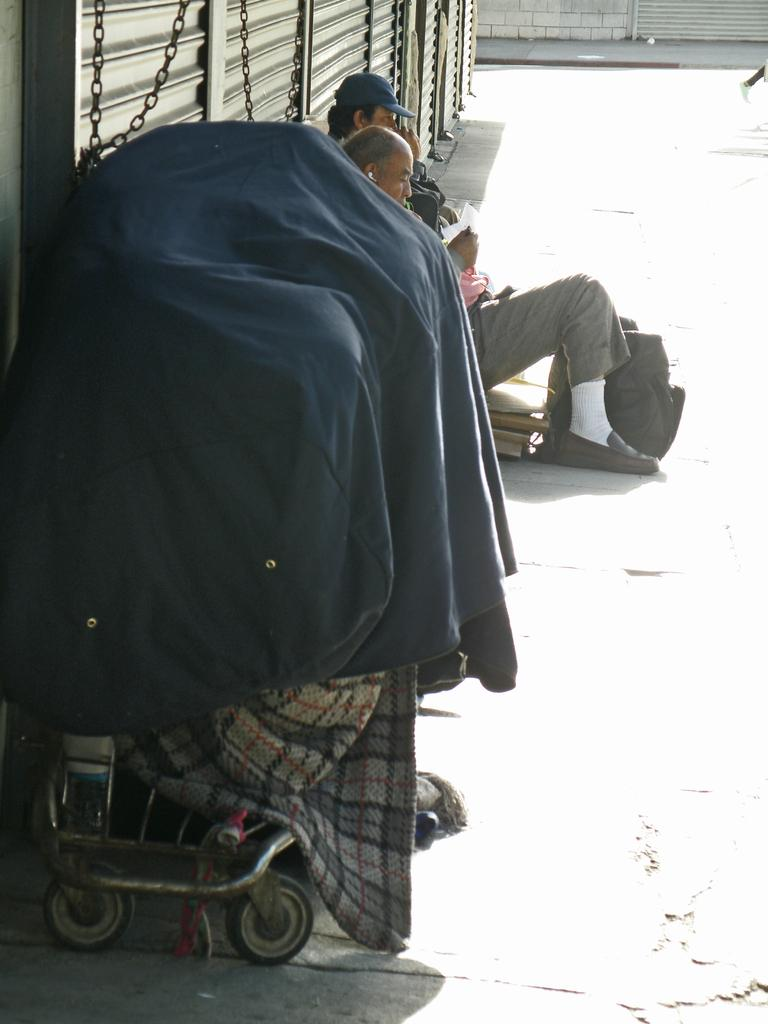What is located on the left side of the image? There is a cart on the left side of the image. What can be seen in the middle of the image? There are two persons in the middle of the image. What type of architectural feature is at the top of the image? There are shutters at the top of the image. What type of selection is available at the front of the cart in the image? There is no information about a selection or the front of the cart in the image. Can you tell me how many quince are present in the image? There is no mention of quince in the image. 